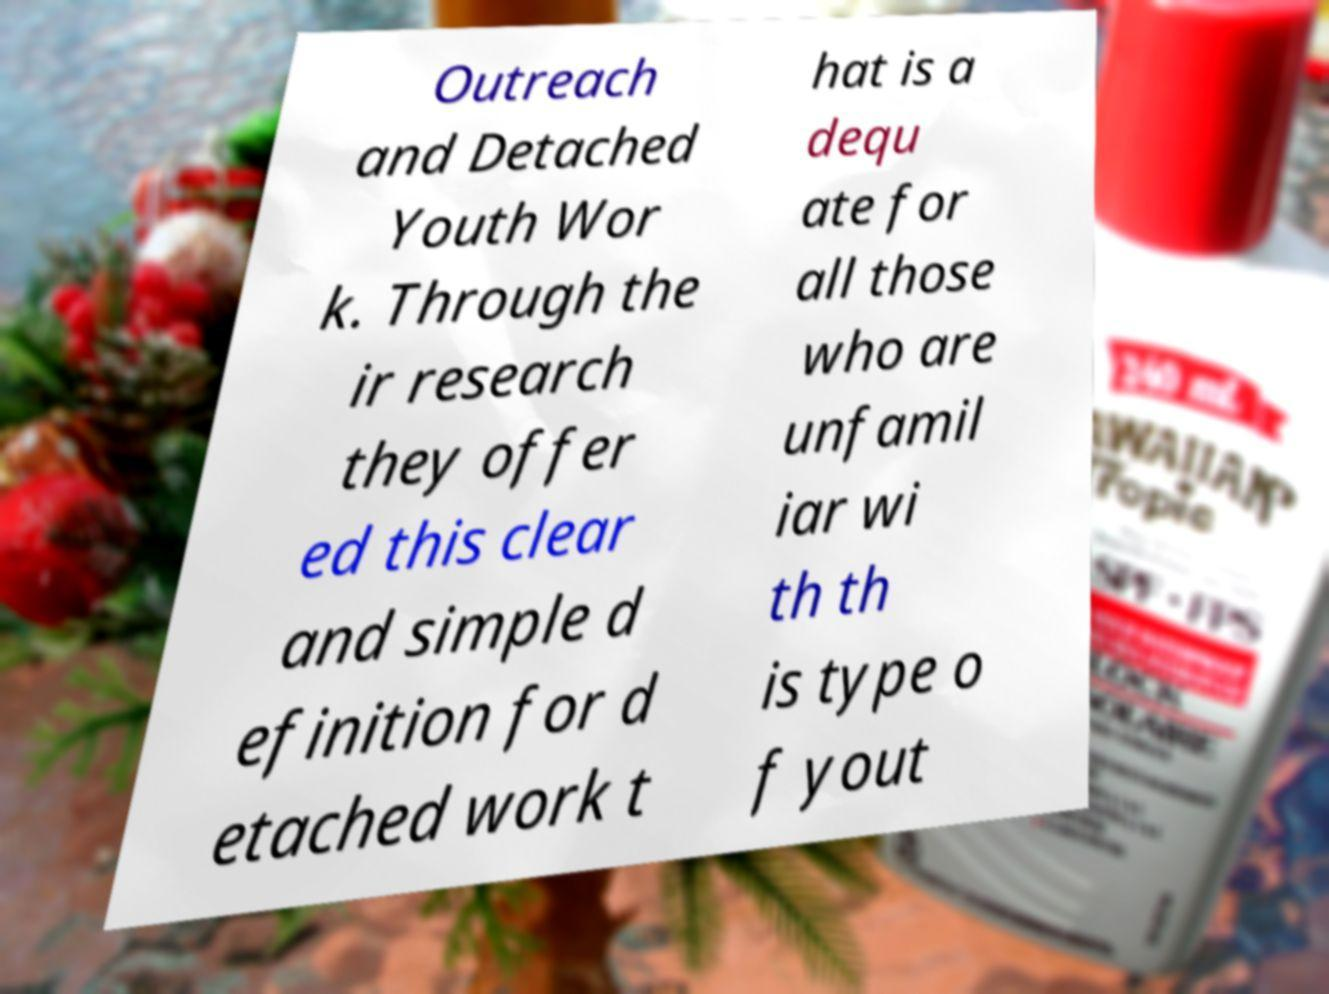There's text embedded in this image that I need extracted. Can you transcribe it verbatim? Outreach and Detached Youth Wor k. Through the ir research they offer ed this clear and simple d efinition for d etached work t hat is a dequ ate for all those who are unfamil iar wi th th is type o f yout 